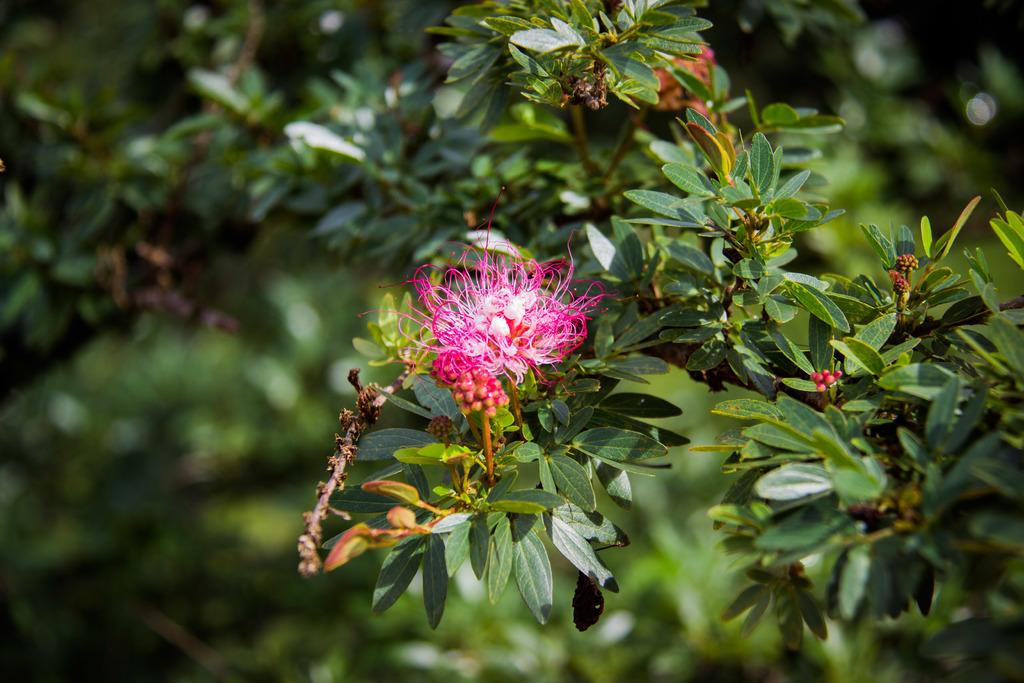What type of flower is present in the image? There is a pink color flower in the image. What other elements can be seen in the image besides the flower? There are many leaves in the image. How would you describe the background of the image? The background of the image is blurred. What songs are being sung by the ball in the winter season in the image? There is no ball or winter season present in the image, and therefore no songs can be sung by a ball in this context. 